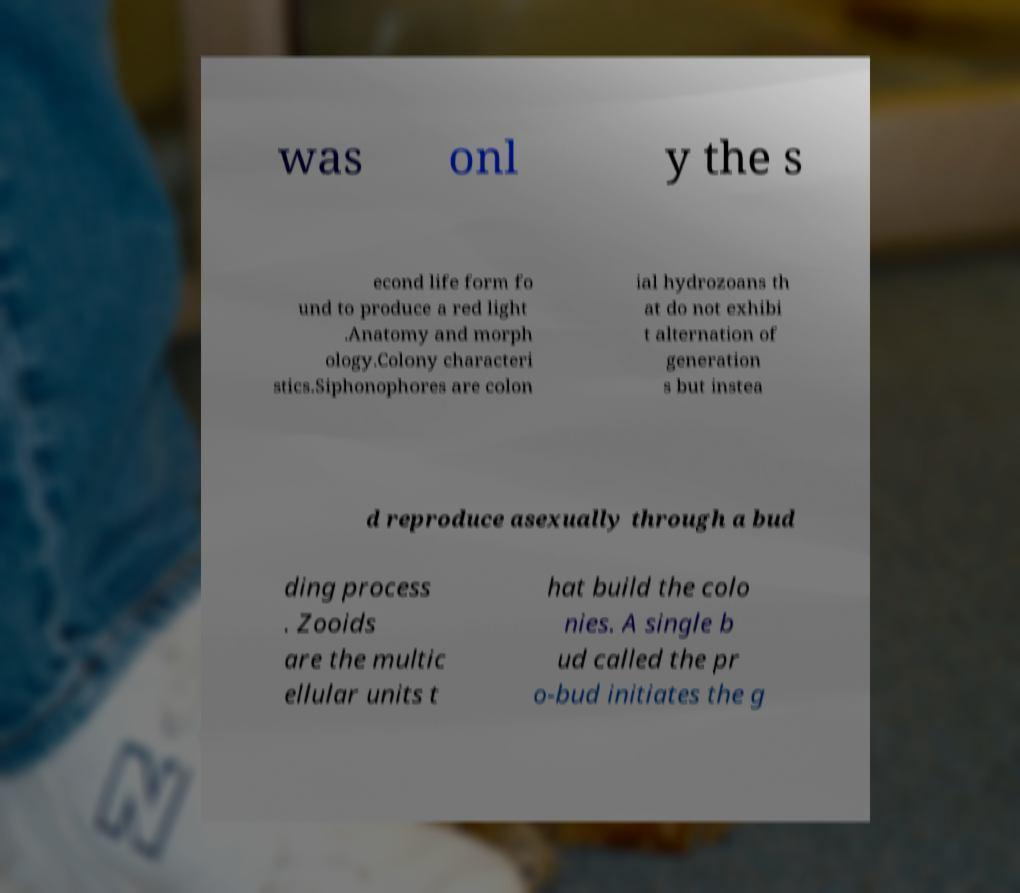For documentation purposes, I need the text within this image transcribed. Could you provide that? was onl y the s econd life form fo und to produce a red light .Anatomy and morph ology.Colony characteri stics.Siphonophores are colon ial hydrozoans th at do not exhibi t alternation of generation s but instea d reproduce asexually through a bud ding process . Zooids are the multic ellular units t hat build the colo nies. A single b ud called the pr o-bud initiates the g 